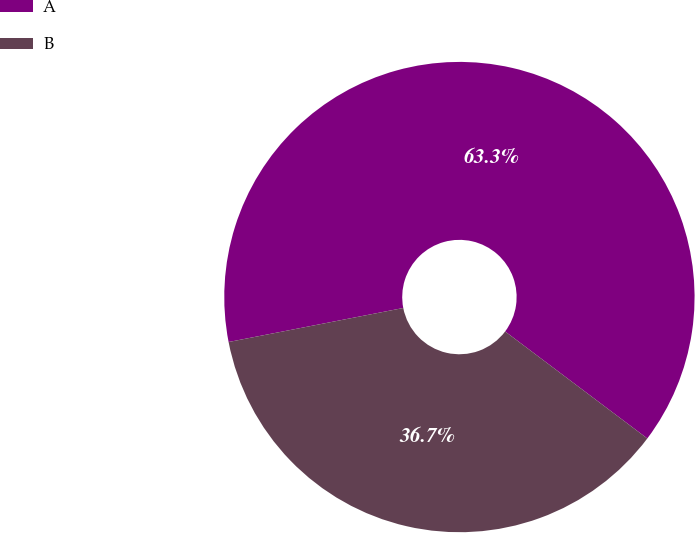Convert chart. <chart><loc_0><loc_0><loc_500><loc_500><pie_chart><fcel>A<fcel>B<nl><fcel>63.33%<fcel>36.67%<nl></chart> 